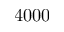Convert formula to latex. <formula><loc_0><loc_0><loc_500><loc_500>4 0 0 0</formula> 